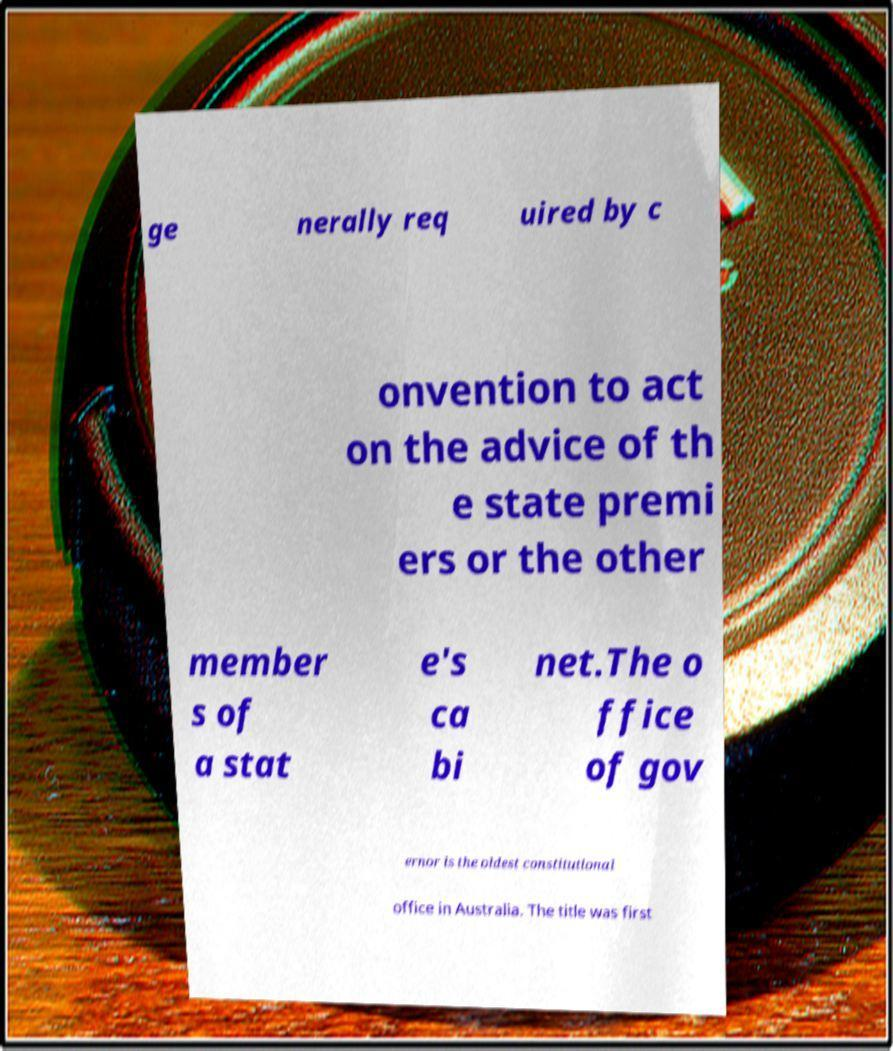Could you extract and type out the text from this image? ge nerally req uired by c onvention to act on the advice of th e state premi ers or the other member s of a stat e's ca bi net.The o ffice of gov ernor is the oldest constitutional office in Australia. The title was first 